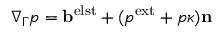Convert formula to latex. <formula><loc_0><loc_0><loc_500><loc_500>\nabla _ { \Gamma } p = \mathbf b ^ { e l s t } + ( p ^ { e x t } + p \kappa ) \mathbf n</formula> 